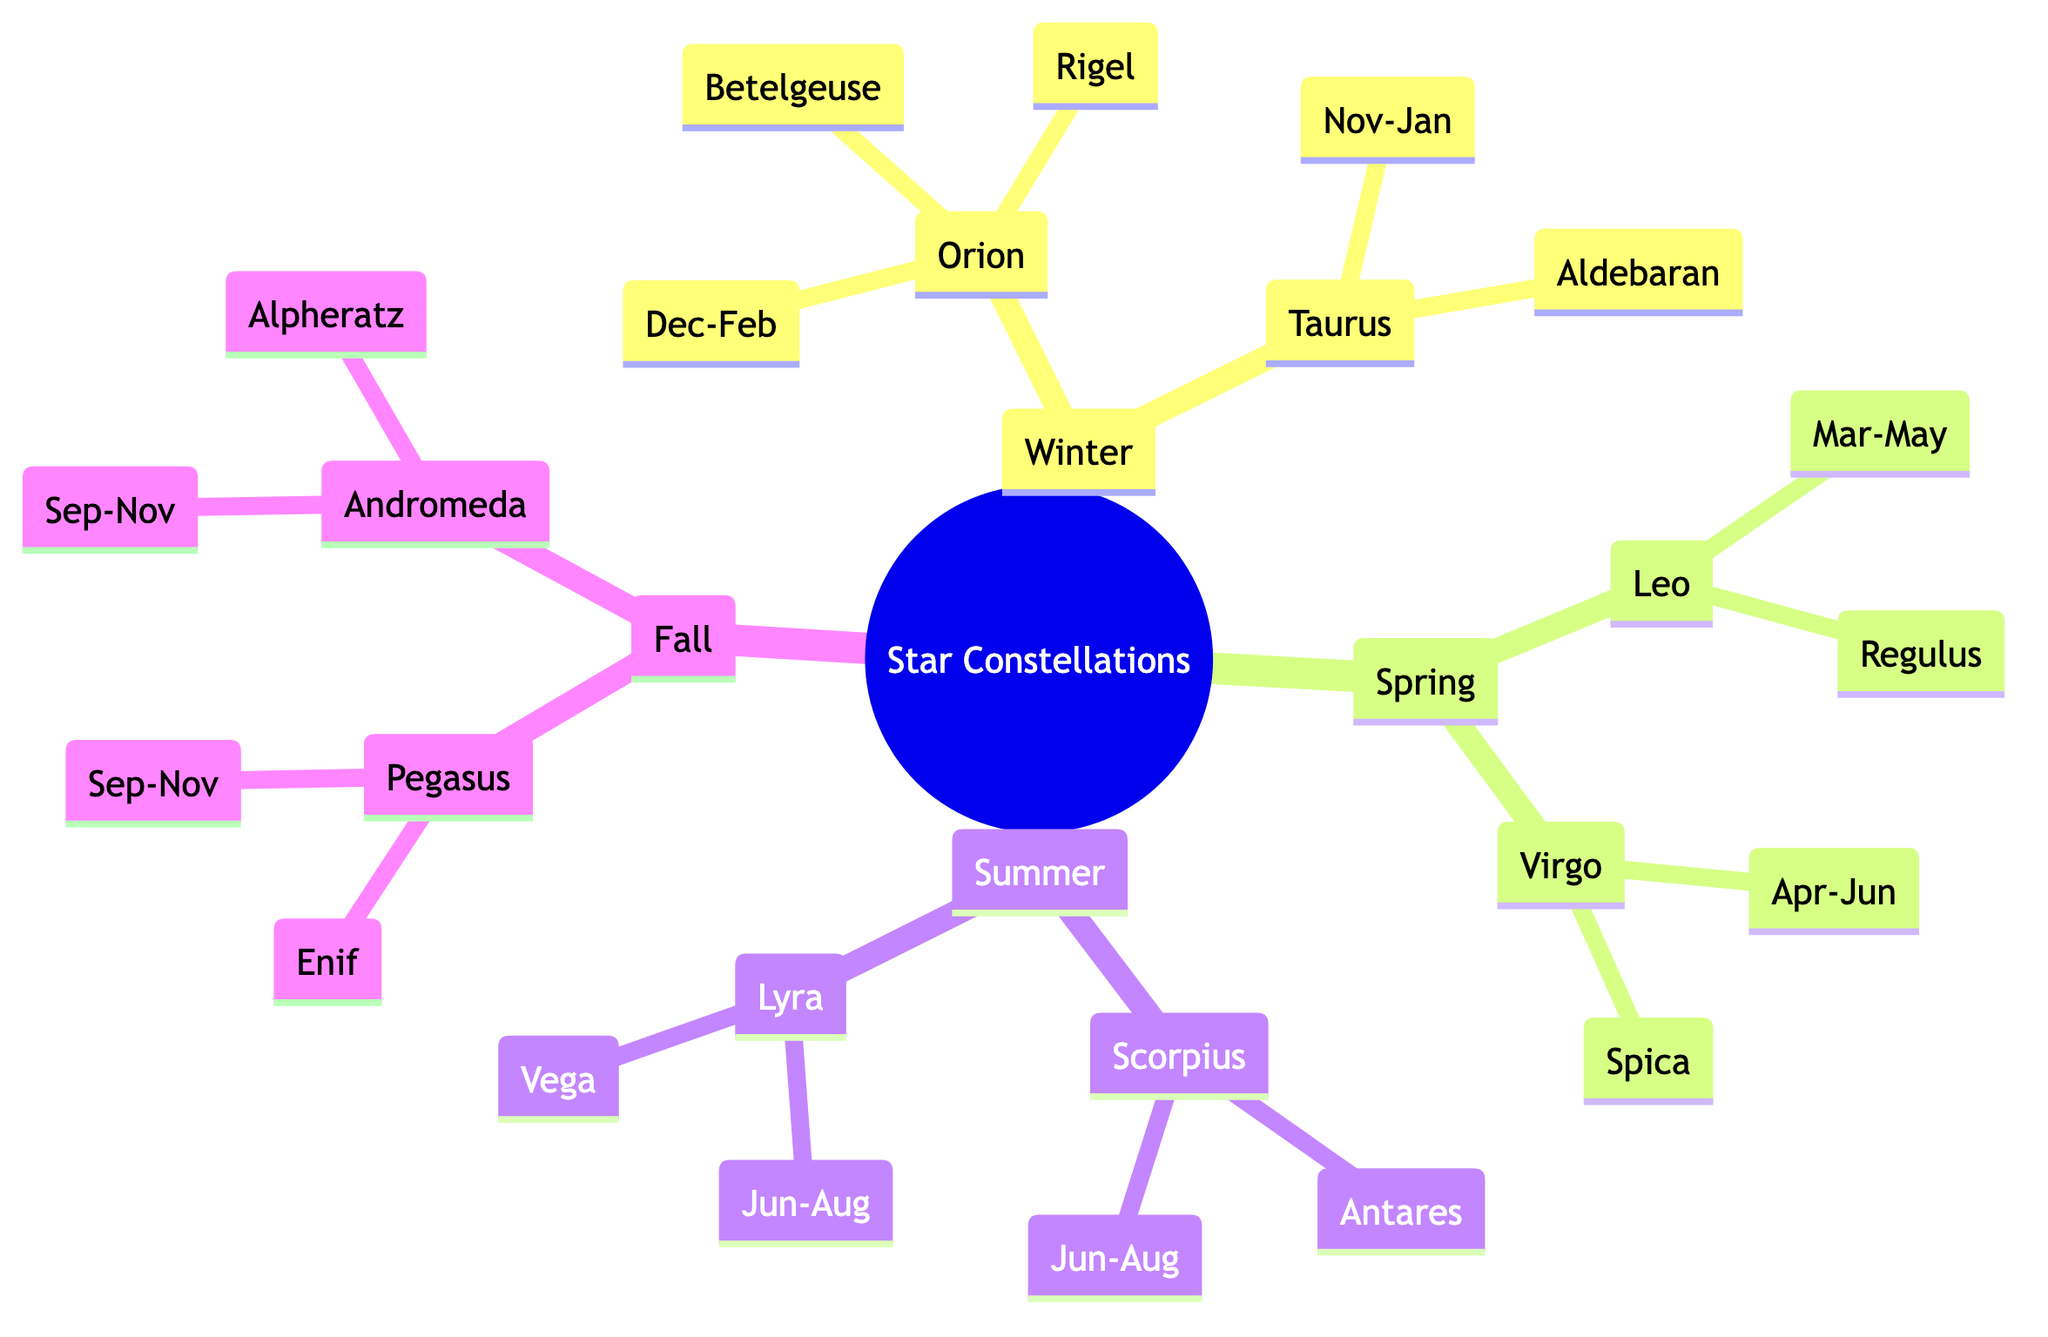What are the primary constellations visible in winter? The diagram lists the constellations for winter, which are Orion and Taurus.
Answer: Orion, Taurus Which star is associated with the constellation Leo? According to the diagram, the star associated with Leo is Regulus.
Answer: Regulus How many constellations are visible in summer? The diagram shows two constellations for summer: Scorpius and Lyra.
Answer: 2 What is the time frame for observing Taurus? The diagram indicates that Taurus can be observed from November to January.
Answer: Nov-Jan Which constellation can be seen during both fall and spring? The diagram shows that there are no constellations that are visible in both fall and spring, as each season has distinct constellations.
Answer: None Which star is associated with the constellation Andromeda? According to the diagram, the star associated with Andromeda is Alpheratz.
Answer: Alpheratz How do the constellations in fall compare to those in winter? The diagram indicates that fall has Pegasus and Andromeda, while winter has Orion and Taurus, showing different constellations for each season.
Answer: Different constellations During which months is Scorpius visible? The diagram states that Scorpius is visible from June to August.
Answer: Jun-Aug What star is found in the constellation Virgo? The diagram indicates that the star associated with Virgo is Spica.
Answer: Spica 